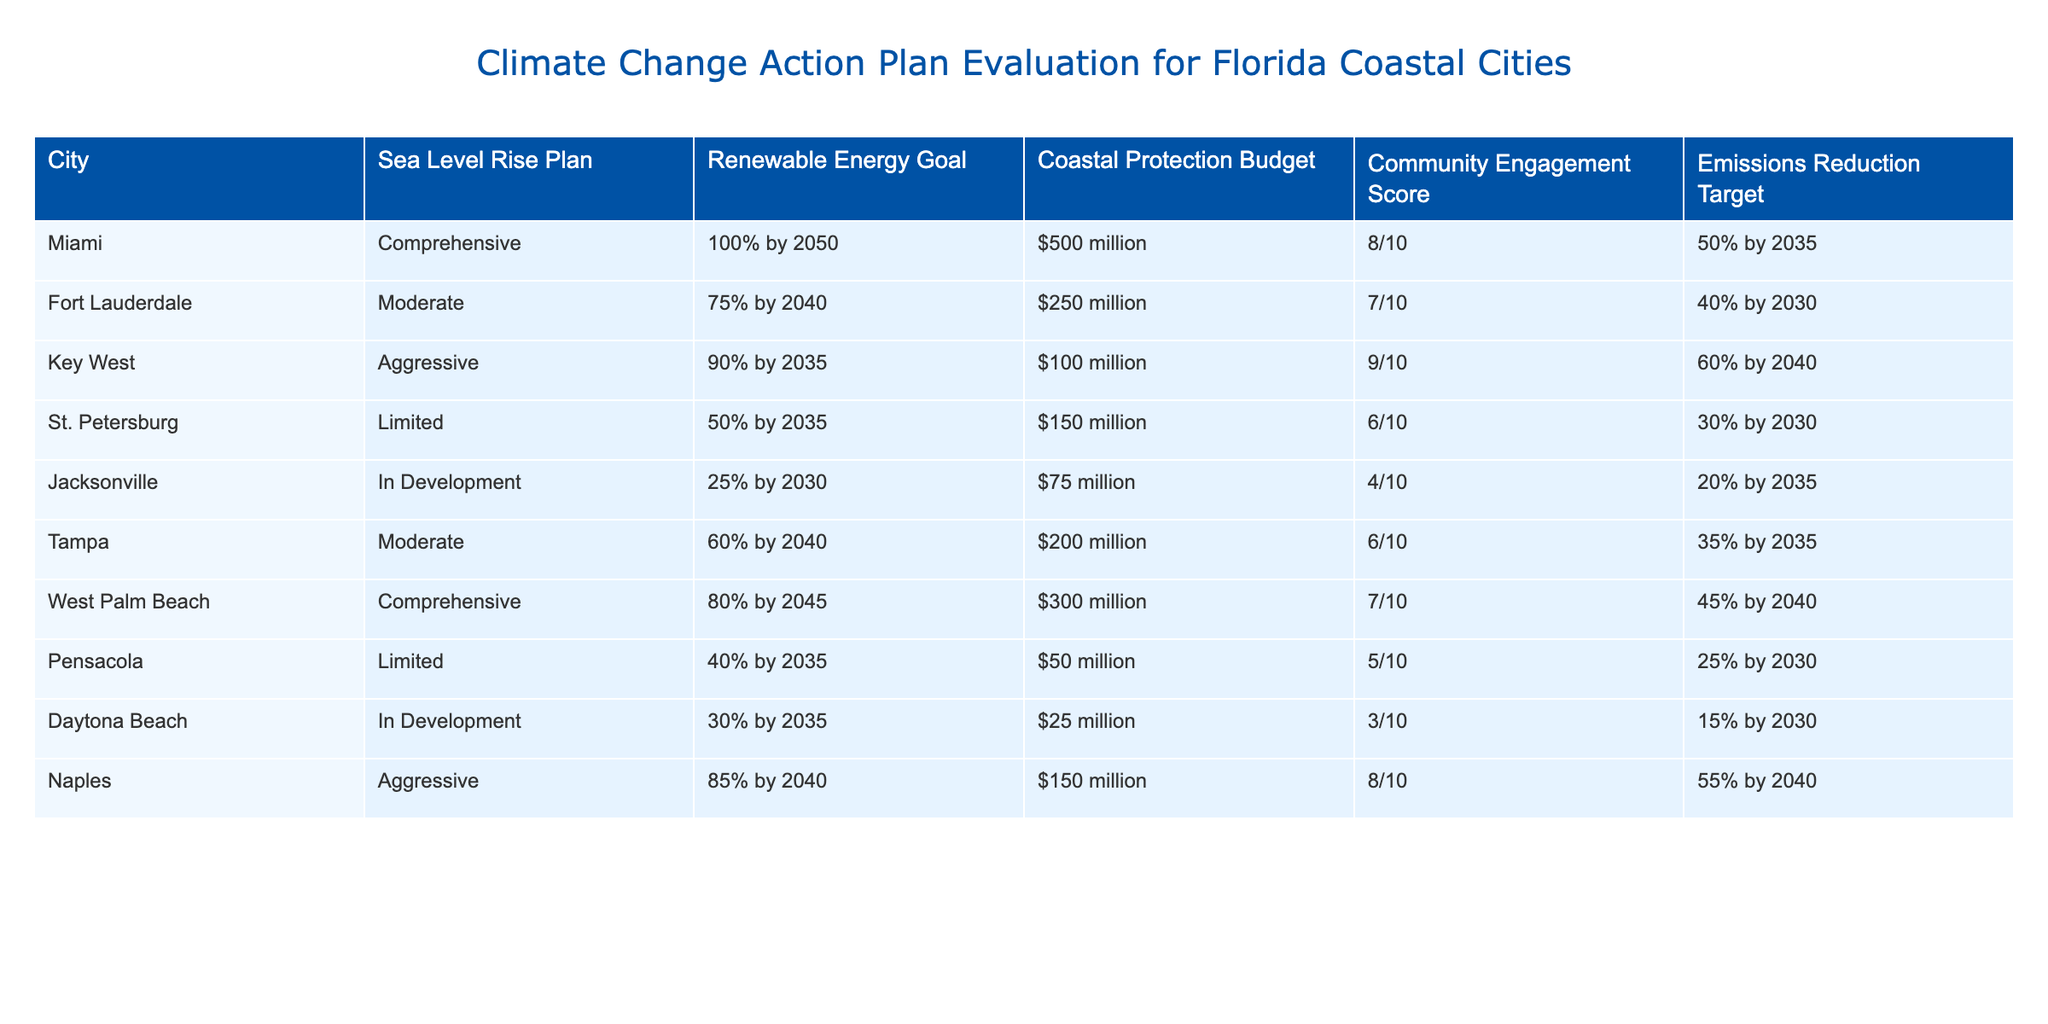What is the community engagement score for Key West? The community engagement score for Key West is listed directly in the table under the corresponding column, which shows a score of 9 out of 10.
Answer: 9/10 Which city has the highest emissions reduction target? Upon reviewing the emissions reduction targets of each city, it is found that Key West has an emissions reduction target of 60% by 2040, the highest among all cities listed.
Answer: Key West What is the difference in the coastal protection budget between Miami and Daytona Beach? The coastal protection budget for Miami is $500 million and for Daytona Beach, it is $25 million. To find the difference, we subtract $25 million from $500 million, resulting in a difference of $475 million.
Answer: $475 million Do any cities have a sea level rise plan that is comprehensive? By inspecting the sea level rise plan column in the table, both Miami and West Palm Beach have a comprehensive sea level rise plan. Thus, the answer is yes.
Answer: Yes What is the average renewable energy goal for all cities listed? To find the average renewable energy goal, we first convert each percentage into numerical values: Miami 100, Fort Lauderdale 75, Key West 90, St. Petersburg 50, Jacksonville 25, Tampa 60, West Palm Beach 80, Pensacola 40, Daytona Beach 30, and Naples 85. Summing these values gives 100 + 75 + 90 + 50 + 25 + 60 + 80 + 40 + 30 + 85 = 735. There are 10 cities, so the average is 735 / 10 = 73.5.
Answer: 73.5 Which city has the lowest community engagement score, and what is that score? Looking at the community engagement scores, Daytona Beach has the lowest score of 3 out of 10. This can be confirmed by comparing the scores across the table.
Answer: 3/10 What is the total budget for coastal protection across all cities? Summing the coastal protection budgets for each city: Miami $500 million + Fort Lauderdale $250 million + Key West $100 million + St. Petersburg $150 million + Jacksonville $75 million + Tampa $200 million + West Palm Beach $300 million + Pensacola $50 million + Daytona Beach $25 million + Naples $150 million gives a total of $1,600 million.
Answer: $1.6 billion Which city has both an aggressive sea level rise plan and the highest emissions reduction target? Key West has an aggressive sea level rise plan and also has the highest emissions reduction target of 60% by 2040 compared to other cities that are either moderate or limited in their approaches.
Answer: Key West How many cities have a renewable energy goal of 75% or higher? By inspecting the renewable energy goal column: Miami 100%, Key West 90%, Naples 85%, West Palm Beach 80%, Fort Lauderdale 75%. There are 5 cities that meet this criterion.
Answer: 5 